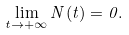<formula> <loc_0><loc_0><loc_500><loc_500>\lim _ { t \to + \infty } N ( t ) = 0 .</formula> 